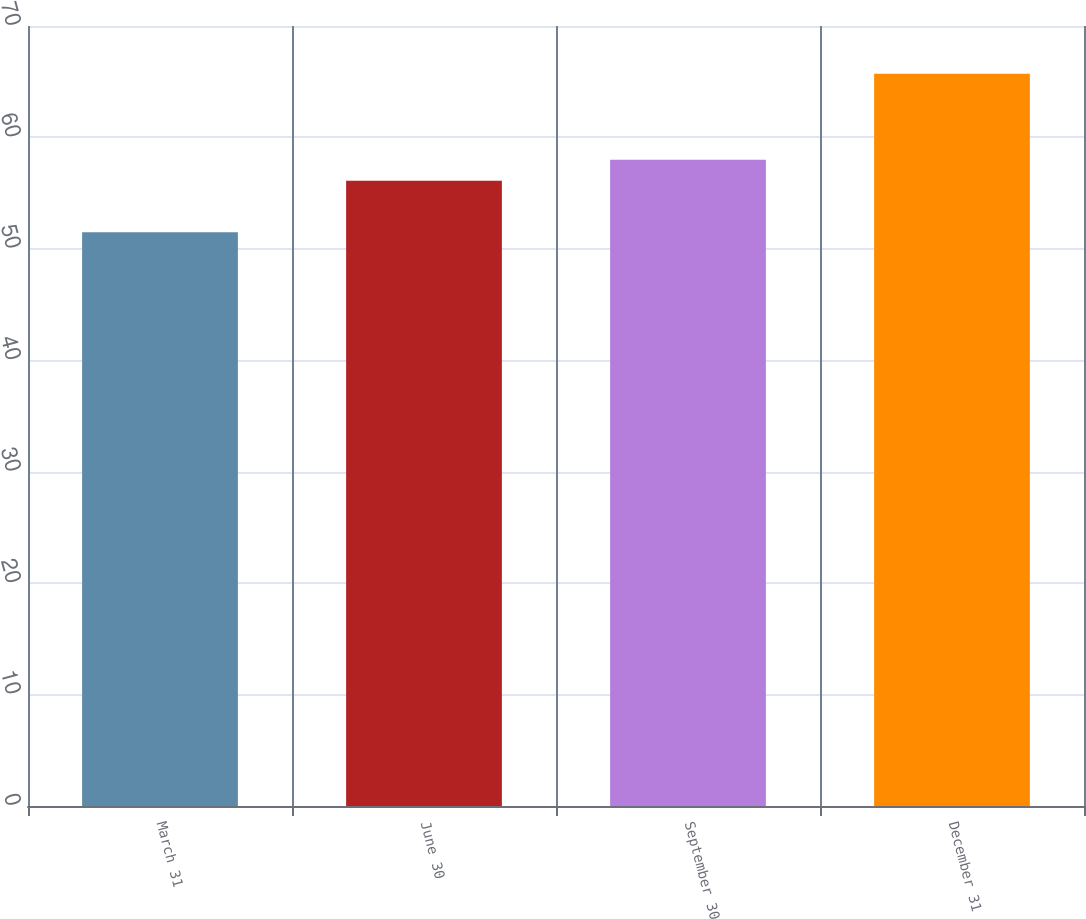<chart> <loc_0><loc_0><loc_500><loc_500><bar_chart><fcel>March 31<fcel>June 30<fcel>September 30<fcel>December 31<nl><fcel>51.49<fcel>56.11<fcel>57.99<fcel>65.72<nl></chart> 